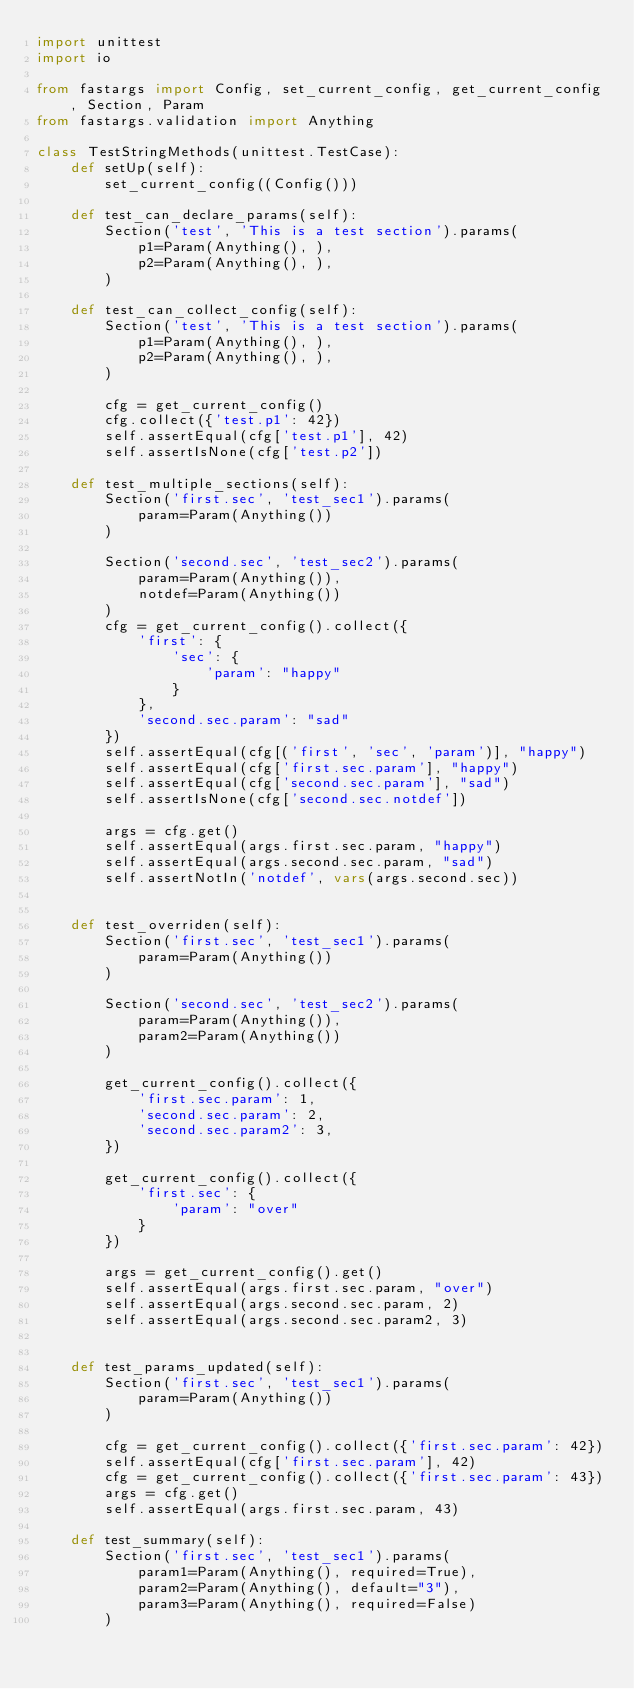<code> <loc_0><loc_0><loc_500><loc_500><_Python_>import unittest
import io

from fastargs import Config, set_current_config, get_current_config, Section, Param
from fastargs.validation import Anything

class TestStringMethods(unittest.TestCase):
    def setUp(self):
        set_current_config((Config()))

    def test_can_declare_params(self):
        Section('test', 'This is a test section').params(
            p1=Param(Anything(), ),
            p2=Param(Anything(), ),
        )

    def test_can_collect_config(self):
        Section('test', 'This is a test section').params(
            p1=Param(Anything(), ),
            p2=Param(Anything(), ),
        )

        cfg = get_current_config()
        cfg.collect({'test.p1': 42})
        self.assertEqual(cfg['test.p1'], 42)
        self.assertIsNone(cfg['test.p2'])

    def test_multiple_sections(self):
        Section('first.sec', 'test_sec1').params(
            param=Param(Anything())
        )

        Section('second.sec', 'test_sec2').params(
            param=Param(Anything()),
            notdef=Param(Anything())
        )
        cfg = get_current_config().collect({
            'first': {
                'sec': {
                    'param': "happy"
                }
            },
            'second.sec.param': "sad"
        })
        self.assertEqual(cfg[('first', 'sec', 'param')], "happy")
        self.assertEqual(cfg['first.sec.param'], "happy")
        self.assertEqual(cfg['second.sec.param'], "sad")
        self.assertIsNone(cfg['second.sec.notdef'])

        args = cfg.get()
        self.assertEqual(args.first.sec.param, "happy")
        self.assertEqual(args.second.sec.param, "sad")
        self.assertNotIn('notdef', vars(args.second.sec))


    def test_overriden(self):
        Section('first.sec', 'test_sec1').params(
            param=Param(Anything())
        )

        Section('second.sec', 'test_sec2').params(
            param=Param(Anything()),
            param2=Param(Anything())
        )

        get_current_config().collect({
            'first.sec.param': 1,
            'second.sec.param': 2,
            'second.sec.param2': 3,
        })

        get_current_config().collect({
            'first.sec': {
                'param': "over"
            }
        })

        args = get_current_config().get()
        self.assertEqual(args.first.sec.param, "over")
        self.assertEqual(args.second.sec.param, 2)
        self.assertEqual(args.second.sec.param2, 3)


    def test_params_updated(self):
        Section('first.sec', 'test_sec1').params(
            param=Param(Anything())
        )

        cfg = get_current_config().collect({'first.sec.param': 42})
        self.assertEqual(cfg['first.sec.param'], 42)
        cfg = get_current_config().collect({'first.sec.param': 43})
        args = cfg.get()
        self.assertEqual(args.first.sec.param, 43)

    def test_summary(self):
        Section('first.sec', 'test_sec1').params(
            param1=Param(Anything(), required=True),
            param2=Param(Anything(), default="3"),
            param3=Param(Anything(), required=False)
        )
</code> 